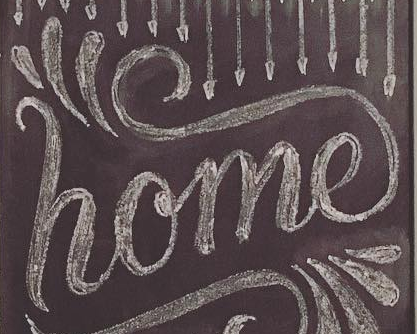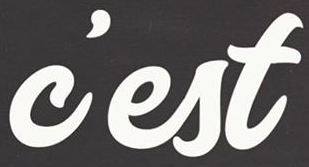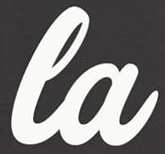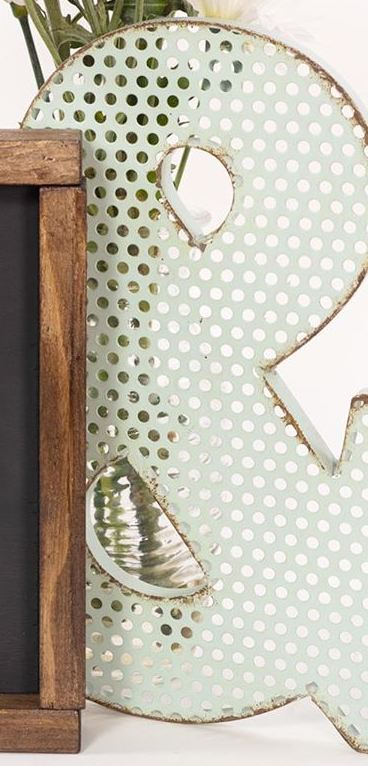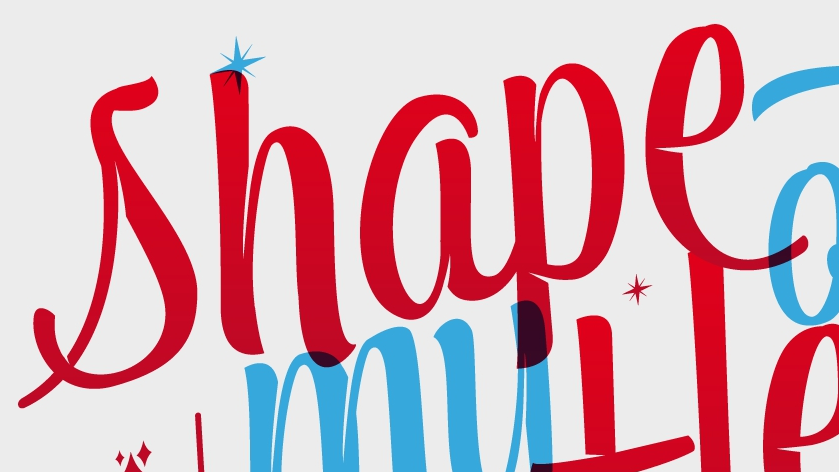What words can you see in these images in sequence, separated by a semicolon? home; c'est; la; &; shape 